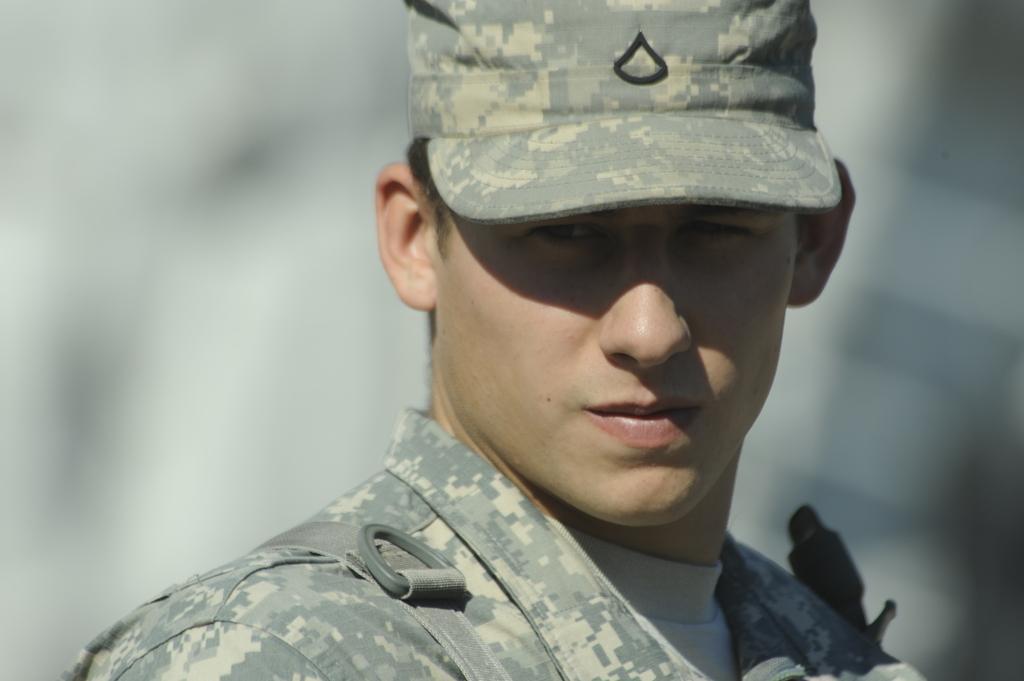In one or two sentences, can you explain what this image depicts? In this image we can see a man and the man is wearing a cap. The background of the image is blurred. 